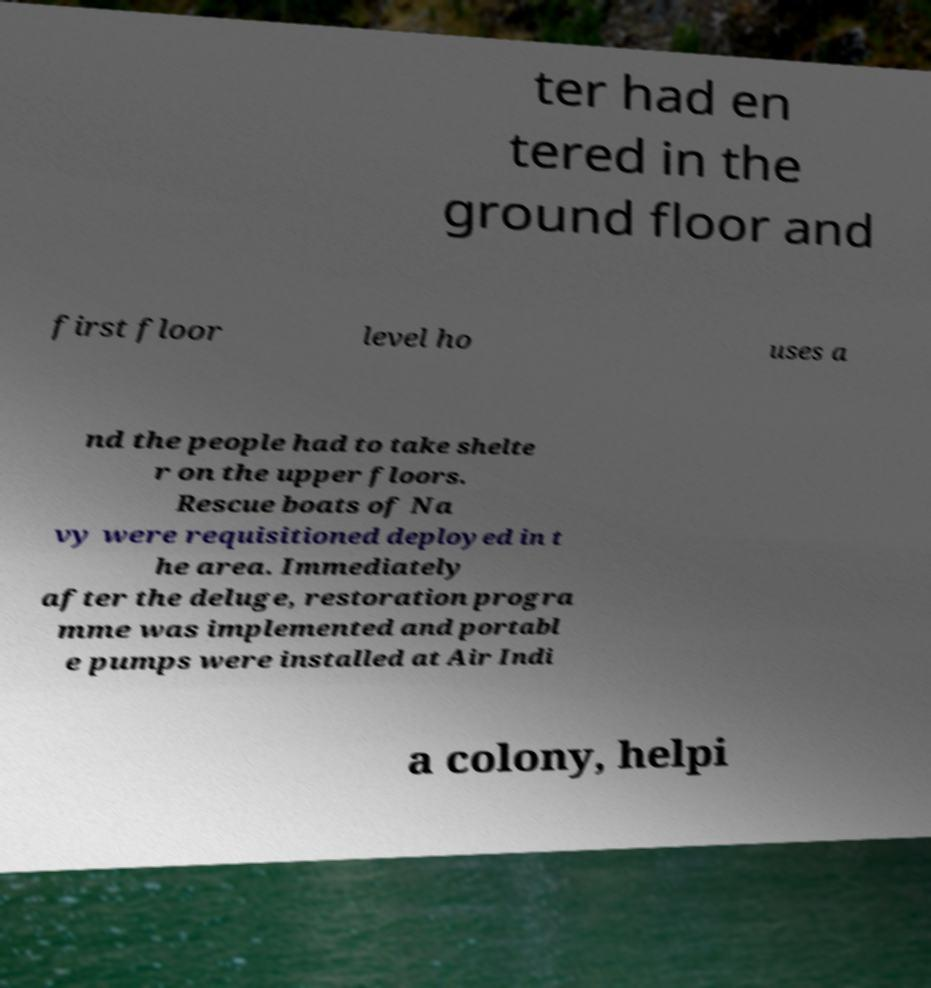Could you extract and type out the text from this image? ter had en tered in the ground floor and first floor level ho uses a nd the people had to take shelte r on the upper floors. Rescue boats of Na vy were requisitioned deployed in t he area. Immediately after the deluge, restoration progra mme was implemented and portabl e pumps were installed at Air Indi a colony, helpi 